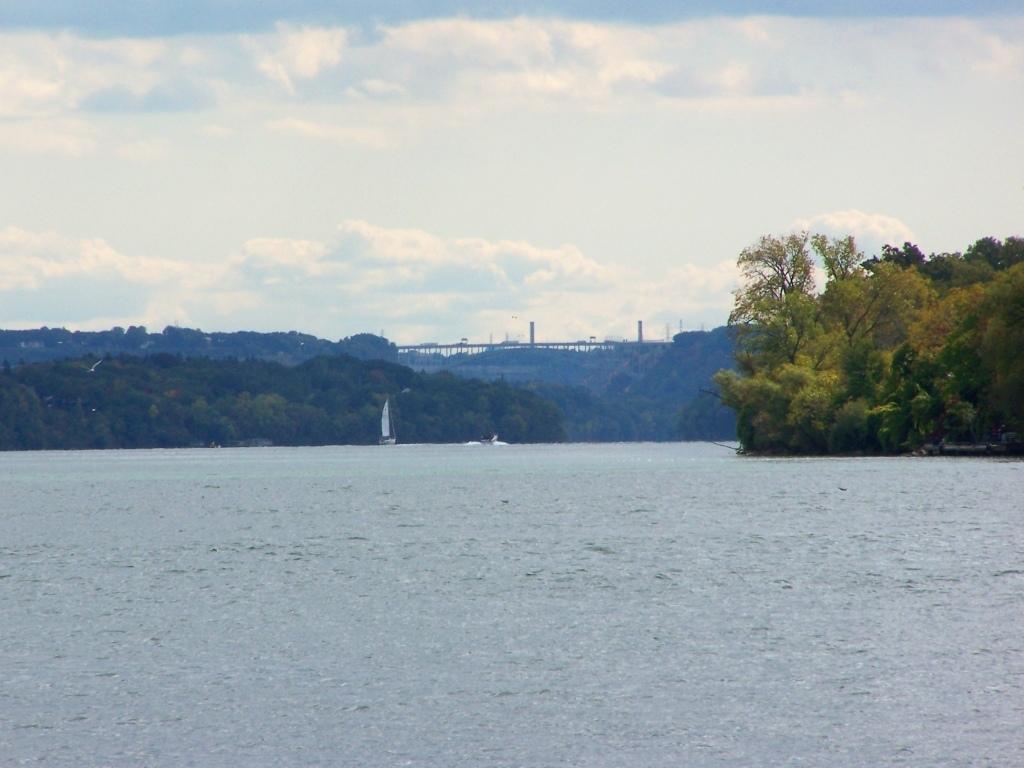Could you give a brief overview of what you see in this image? In this image I can see few trees, poles, boats on the water surface. The sky is in white and blue color. 